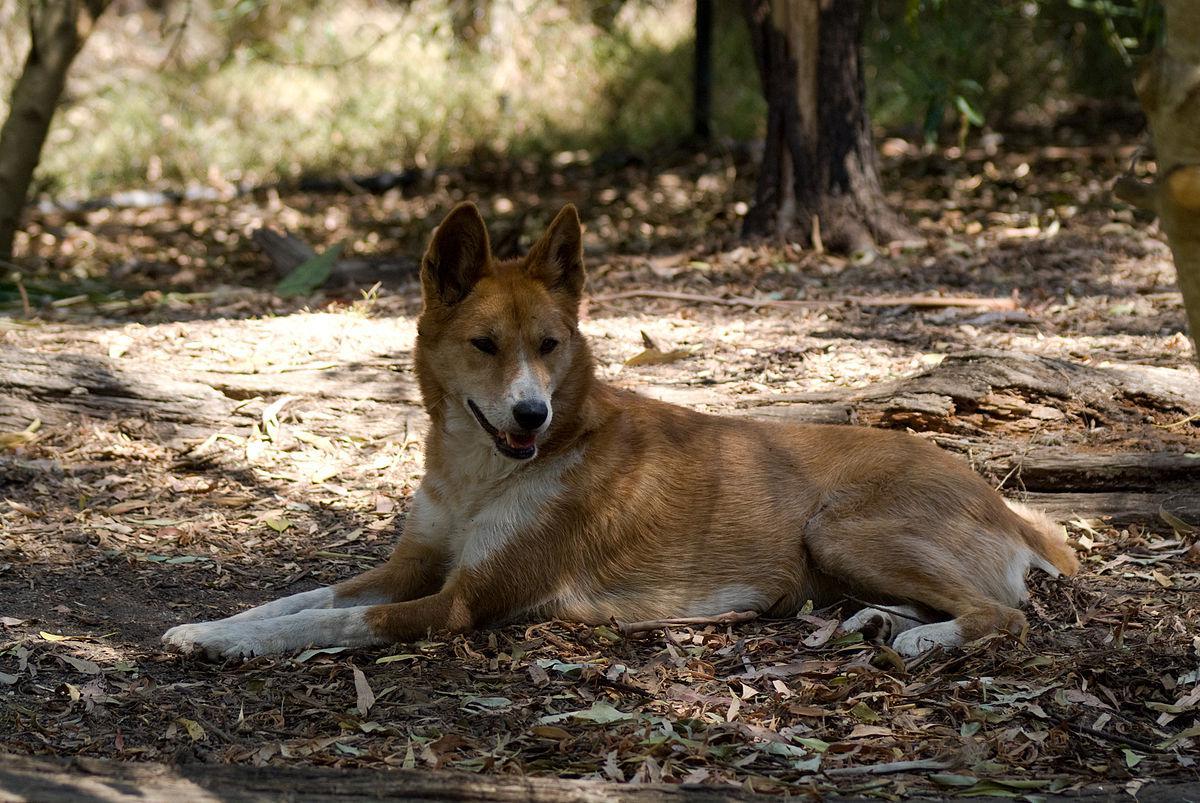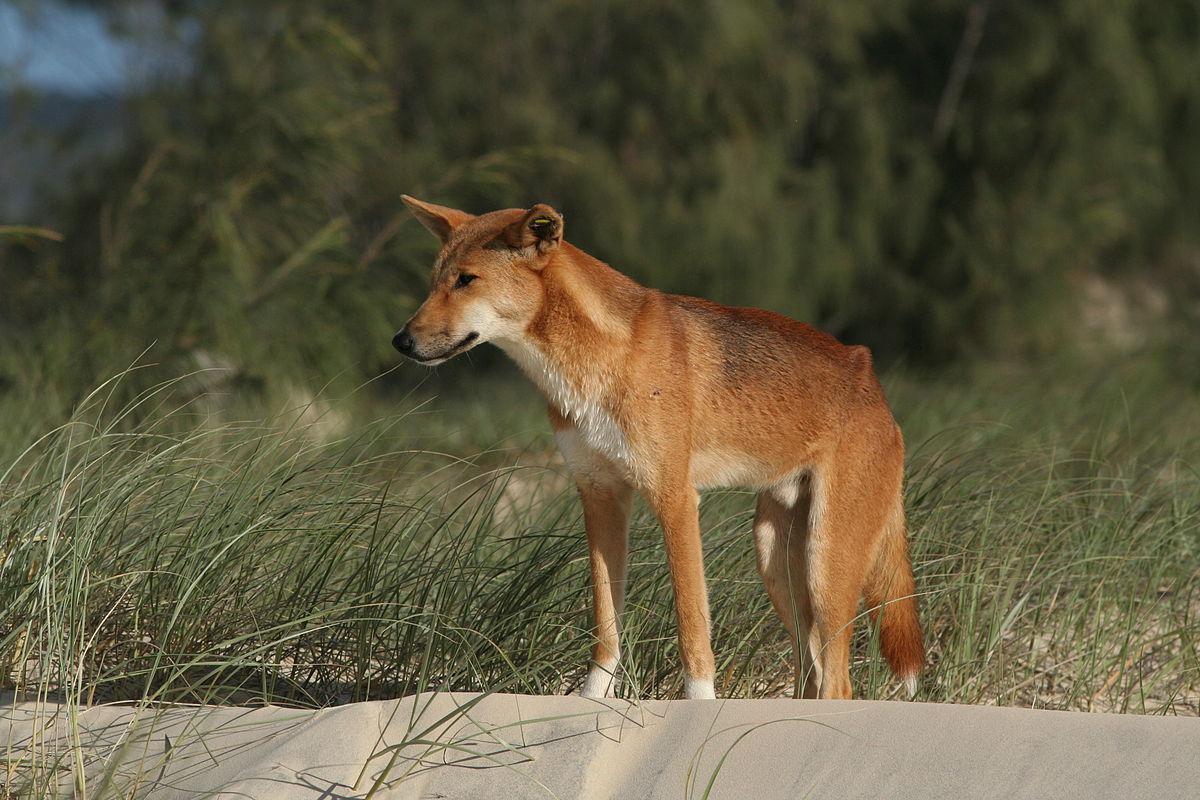The first image is the image on the left, the second image is the image on the right. Considering the images on both sides, is "An image shows one leftward-gazing wild dog standing in tall grass." valid? Answer yes or no. Yes. The first image is the image on the left, the second image is the image on the right. Evaluate the accuracy of this statement regarding the images: "The dog in the image on the left is lying with its mouth open.". Is it true? Answer yes or no. Yes. 